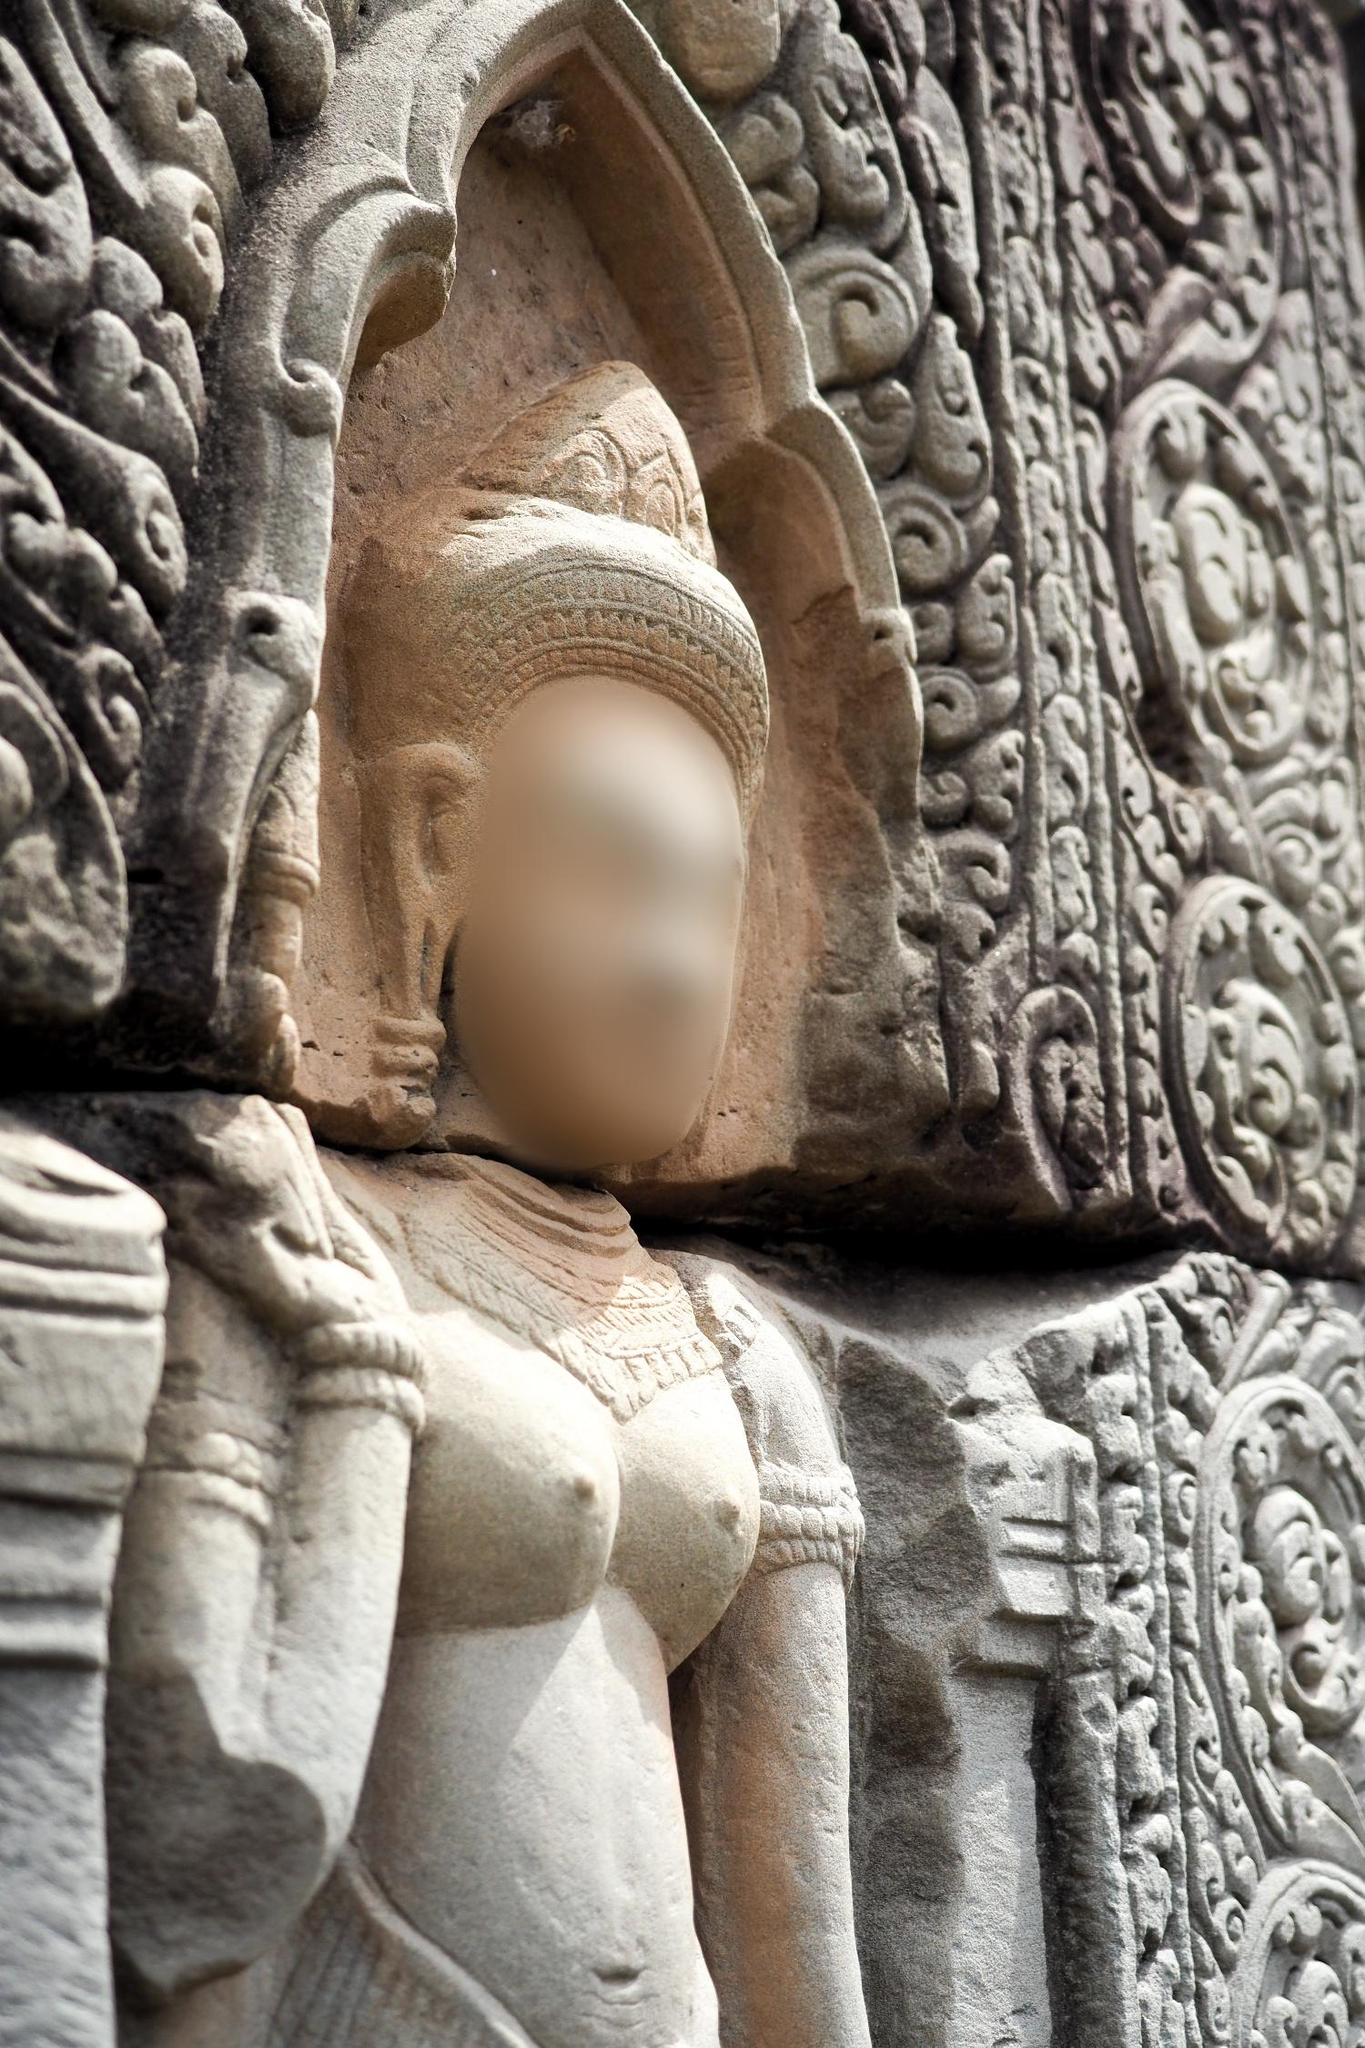What emotions do you think the statue was meant to evoke in viewers? The statue was likely meant to evoke emotions of reverence, awe, and tranquility in its viewers. Its majestic and serene demeanor, along with the intricate detailing, invites admiration for the divine or regal figure it represents. The blurred face introduces a sense of mystery and introspection, encouraging viewers to look beyond the physical and ponder deeper spiritual or philosophical thoughts. The grandeur and timeless quality of the statue might also stir feelings of historical connection and cultural pride, as viewers contemplate the rich heritage and skilled artistry that crafted such a monumental piece. How would the setting affect the statue's appearance over centuries? Over centuries, the setting would significantly affect the statue’s appearance. Exposure to the elements would gradually wear down the finer details, giving the statue a weathered, venerable look. The stone might develop a patina or layers of moss and lichen could start to cloak it, merging it further into its natural surroundings. Despite these changes, the statue would gain a timeless, enduring quality, becoming a storied relic weathered by time. Such aging would make it a blend of nature’s embrace and human craftsmanship, each mark a testament to the passage of countless seasons and the silent watch of centuries. What kind of rituals or ceremonies might have taken place in the presence of this statue? In the presence of this statue, numerous rituals and ceremonies might have taken place. Worshippers may have presented offerings such as flowers, incense, and food at its base, seeking blessings or divine favor. There could have been elaborate ceremonies involving chanting, music, and dance, celebrating festivals or marking significant religious observances. The statue might have been a focal point during rites of passage, such as weddings or coming-of-age rituals. Furthermore, it could have played a role in meditative practices, as devotees sought spiritual enlightenment or guidance. Each ceremony, whether grand or personal, would have added to the sacred aura enveloping the statue, imbuing it with layers of spiritual significance. In a realistic scenario, what might be the challenges faced in preserving this statue today? In a realistic scenario, preserving this statue today would present several challenges. Environmental factors such as weathering, pollution, and biological growth like moss and lichen can gradually deteriorate the stone. Human activities, including vandalism, tourism, and neglect, pose additional threats. Ensuring that preservation methods do not damage the statue is crucial, requiring expertise in conservation and often, significant funding. Balancing accessibility to the public with protection against physical harm is another challenge. Efforts must be made to safeguard this cultural treasure while maintaining its historical and aesthetic integrity. 